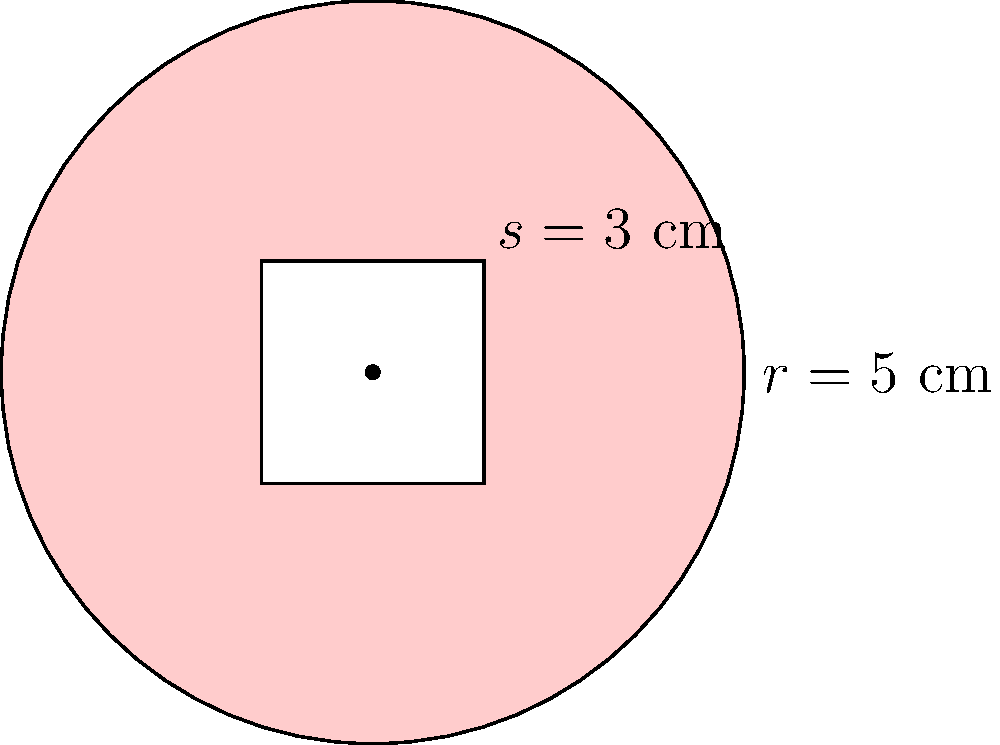Your child's favorite pizza place has introduced a new square-cut pizza. The pizza is circular with a radius of 5 cm, but it has a square hole cut out of the center, with the side length of the square being 3 cm. How much pizza area (in square centimeters) is left for your child to enjoy? Round your answer to the nearest whole number. Let's approach this step-by-step:

1) First, we need to calculate the area of the entire circular pizza:
   Area of circle = $\pi r^2$
   $A_{circle} = \pi \cdot 5^2 = 25\pi$ cm²

2) Next, we calculate the area of the square hole:
   Area of square = $s^2$
   $A_{square} = 3^2 = 9$ cm²

3) The remaining pizza area is the difference between these two:
   $A_{remaining} = A_{circle} - A_{square}$
   $A_{remaining} = 25\pi - 9$ cm²

4) Let's calculate this:
   $25\pi \approx 78.54$ cm²
   $78.54 - 9 = 69.54$ cm²

5) Rounding to the nearest whole number:
   $69.54$ rounds to $70$ cm²

This approach allows your child to enjoy most of the pizza while introducing a fun shape, without subjecting them to intense training methods.
Answer: 70 cm² 